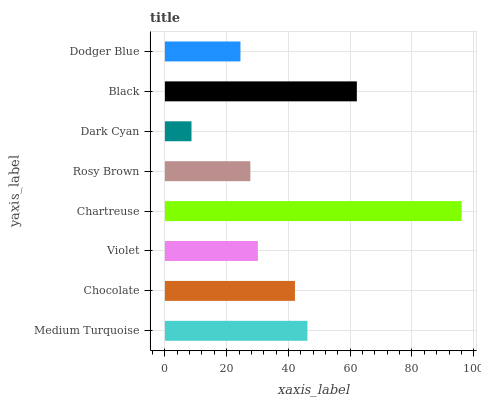Is Dark Cyan the minimum?
Answer yes or no. Yes. Is Chartreuse the maximum?
Answer yes or no. Yes. Is Chocolate the minimum?
Answer yes or no. No. Is Chocolate the maximum?
Answer yes or no. No. Is Medium Turquoise greater than Chocolate?
Answer yes or no. Yes. Is Chocolate less than Medium Turquoise?
Answer yes or no. Yes. Is Chocolate greater than Medium Turquoise?
Answer yes or no. No. Is Medium Turquoise less than Chocolate?
Answer yes or no. No. Is Chocolate the high median?
Answer yes or no. Yes. Is Violet the low median?
Answer yes or no. Yes. Is Medium Turquoise the high median?
Answer yes or no. No. Is Chartreuse the low median?
Answer yes or no. No. 